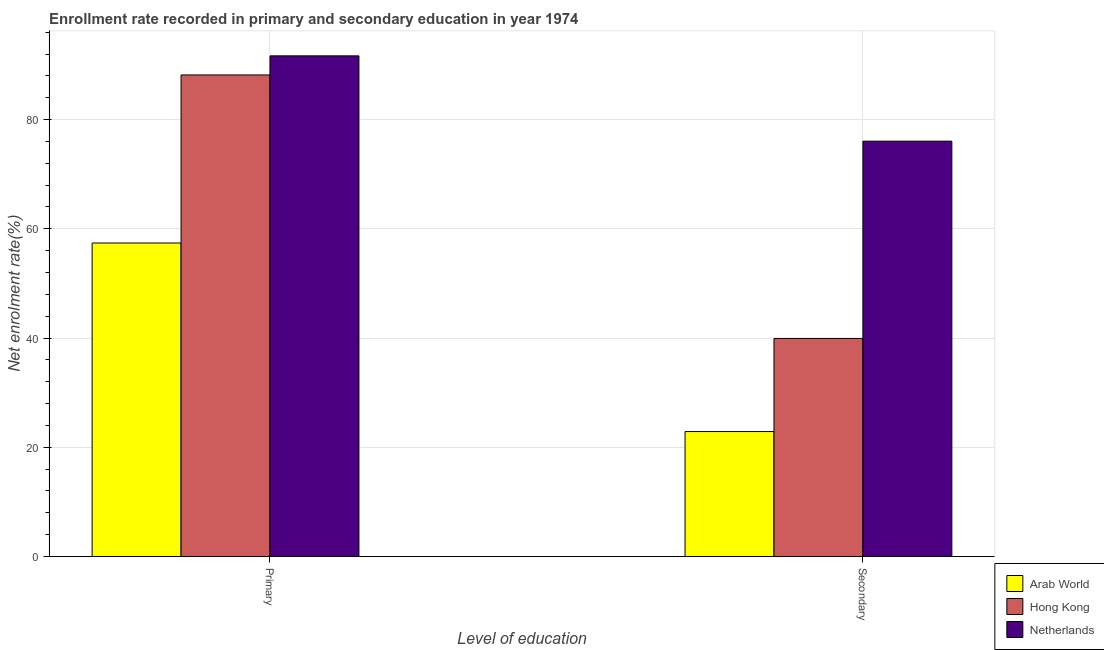How many different coloured bars are there?
Offer a terse response. 3. Are the number of bars per tick equal to the number of legend labels?
Offer a very short reply. Yes. How many bars are there on the 1st tick from the left?
Your answer should be compact. 3. What is the label of the 2nd group of bars from the left?
Ensure brevity in your answer.  Secondary. What is the enrollment rate in primary education in Netherlands?
Offer a terse response. 91.67. Across all countries, what is the maximum enrollment rate in secondary education?
Your answer should be very brief. 76.05. Across all countries, what is the minimum enrollment rate in secondary education?
Your answer should be compact. 22.88. In which country was the enrollment rate in secondary education maximum?
Your response must be concise. Netherlands. In which country was the enrollment rate in primary education minimum?
Your answer should be very brief. Arab World. What is the total enrollment rate in secondary education in the graph?
Keep it short and to the point. 138.86. What is the difference between the enrollment rate in secondary education in Hong Kong and that in Arab World?
Keep it short and to the point. 17.05. What is the difference between the enrollment rate in secondary education in Hong Kong and the enrollment rate in primary education in Netherlands?
Offer a very short reply. -51.74. What is the average enrollment rate in secondary education per country?
Give a very brief answer. 46.29. What is the difference between the enrollment rate in primary education and enrollment rate in secondary education in Arab World?
Make the answer very short. 34.52. What is the ratio of the enrollment rate in secondary education in Hong Kong to that in Arab World?
Your answer should be very brief. 1.74. What does the 1st bar from the left in Primary represents?
Offer a very short reply. Arab World. How many bars are there?
Your answer should be compact. 6. Are all the bars in the graph horizontal?
Provide a short and direct response. No. How many countries are there in the graph?
Ensure brevity in your answer.  3. What is the difference between two consecutive major ticks on the Y-axis?
Offer a terse response. 20. Does the graph contain any zero values?
Offer a very short reply. No. Does the graph contain grids?
Your answer should be compact. Yes. What is the title of the graph?
Give a very brief answer. Enrollment rate recorded in primary and secondary education in year 1974. Does "Norway" appear as one of the legend labels in the graph?
Make the answer very short. No. What is the label or title of the X-axis?
Provide a short and direct response. Level of education. What is the label or title of the Y-axis?
Provide a succinct answer. Net enrolment rate(%). What is the Net enrolment rate(%) in Arab World in Primary?
Provide a succinct answer. 57.4. What is the Net enrolment rate(%) of Hong Kong in Primary?
Your answer should be compact. 88.17. What is the Net enrolment rate(%) of Netherlands in Primary?
Give a very brief answer. 91.67. What is the Net enrolment rate(%) of Arab World in Secondary?
Make the answer very short. 22.88. What is the Net enrolment rate(%) in Hong Kong in Secondary?
Ensure brevity in your answer.  39.93. What is the Net enrolment rate(%) in Netherlands in Secondary?
Offer a terse response. 76.05. Across all Level of education, what is the maximum Net enrolment rate(%) of Arab World?
Offer a very short reply. 57.4. Across all Level of education, what is the maximum Net enrolment rate(%) in Hong Kong?
Make the answer very short. 88.17. Across all Level of education, what is the maximum Net enrolment rate(%) in Netherlands?
Keep it short and to the point. 91.67. Across all Level of education, what is the minimum Net enrolment rate(%) in Arab World?
Offer a terse response. 22.88. Across all Level of education, what is the minimum Net enrolment rate(%) of Hong Kong?
Offer a terse response. 39.93. Across all Level of education, what is the minimum Net enrolment rate(%) of Netherlands?
Your answer should be very brief. 76.05. What is the total Net enrolment rate(%) in Arab World in the graph?
Your answer should be very brief. 80.29. What is the total Net enrolment rate(%) of Hong Kong in the graph?
Make the answer very short. 128.1. What is the total Net enrolment rate(%) of Netherlands in the graph?
Ensure brevity in your answer.  167.72. What is the difference between the Net enrolment rate(%) in Arab World in Primary and that in Secondary?
Ensure brevity in your answer.  34.52. What is the difference between the Net enrolment rate(%) of Hong Kong in Primary and that in Secondary?
Ensure brevity in your answer.  48.24. What is the difference between the Net enrolment rate(%) of Netherlands in Primary and that in Secondary?
Ensure brevity in your answer.  15.62. What is the difference between the Net enrolment rate(%) of Arab World in Primary and the Net enrolment rate(%) of Hong Kong in Secondary?
Make the answer very short. 17.47. What is the difference between the Net enrolment rate(%) in Arab World in Primary and the Net enrolment rate(%) in Netherlands in Secondary?
Provide a short and direct response. -18.65. What is the difference between the Net enrolment rate(%) in Hong Kong in Primary and the Net enrolment rate(%) in Netherlands in Secondary?
Provide a short and direct response. 12.12. What is the average Net enrolment rate(%) of Arab World per Level of education?
Provide a succinct answer. 40.14. What is the average Net enrolment rate(%) in Hong Kong per Level of education?
Your answer should be very brief. 64.05. What is the average Net enrolment rate(%) in Netherlands per Level of education?
Offer a terse response. 83.86. What is the difference between the Net enrolment rate(%) in Arab World and Net enrolment rate(%) in Hong Kong in Primary?
Provide a short and direct response. -30.77. What is the difference between the Net enrolment rate(%) of Arab World and Net enrolment rate(%) of Netherlands in Primary?
Your answer should be compact. -34.27. What is the difference between the Net enrolment rate(%) in Hong Kong and Net enrolment rate(%) in Netherlands in Primary?
Offer a terse response. -3.49. What is the difference between the Net enrolment rate(%) in Arab World and Net enrolment rate(%) in Hong Kong in Secondary?
Provide a short and direct response. -17.05. What is the difference between the Net enrolment rate(%) in Arab World and Net enrolment rate(%) in Netherlands in Secondary?
Give a very brief answer. -53.17. What is the difference between the Net enrolment rate(%) of Hong Kong and Net enrolment rate(%) of Netherlands in Secondary?
Make the answer very short. -36.12. What is the ratio of the Net enrolment rate(%) in Arab World in Primary to that in Secondary?
Give a very brief answer. 2.51. What is the ratio of the Net enrolment rate(%) in Hong Kong in Primary to that in Secondary?
Make the answer very short. 2.21. What is the ratio of the Net enrolment rate(%) of Netherlands in Primary to that in Secondary?
Your answer should be very brief. 1.21. What is the difference between the highest and the second highest Net enrolment rate(%) of Arab World?
Ensure brevity in your answer.  34.52. What is the difference between the highest and the second highest Net enrolment rate(%) of Hong Kong?
Make the answer very short. 48.24. What is the difference between the highest and the second highest Net enrolment rate(%) of Netherlands?
Provide a succinct answer. 15.62. What is the difference between the highest and the lowest Net enrolment rate(%) of Arab World?
Ensure brevity in your answer.  34.52. What is the difference between the highest and the lowest Net enrolment rate(%) of Hong Kong?
Offer a terse response. 48.24. What is the difference between the highest and the lowest Net enrolment rate(%) in Netherlands?
Offer a terse response. 15.62. 